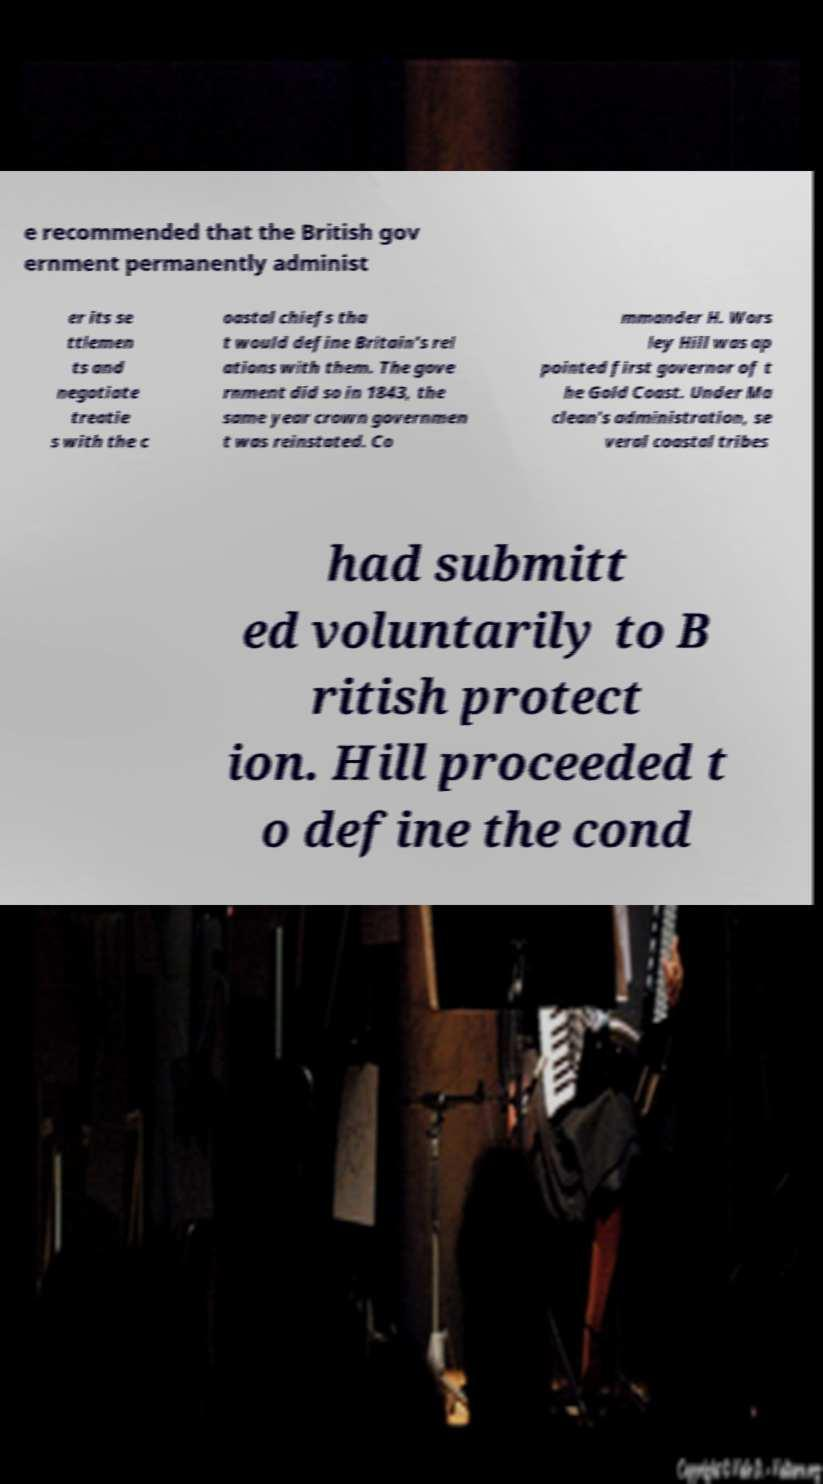Could you extract and type out the text from this image? e recommended that the British gov ernment permanently administ er its se ttlemen ts and negotiate treatie s with the c oastal chiefs tha t would define Britain's rel ations with them. The gove rnment did so in 1843, the same year crown governmen t was reinstated. Co mmander H. Wors ley Hill was ap pointed first governor of t he Gold Coast. Under Ma clean's administration, se veral coastal tribes had submitt ed voluntarily to B ritish protect ion. Hill proceeded t o define the cond 